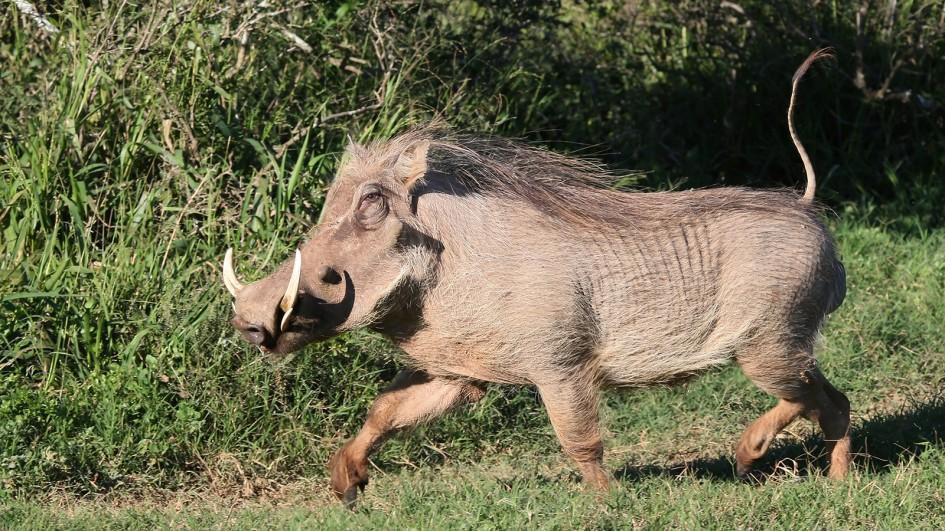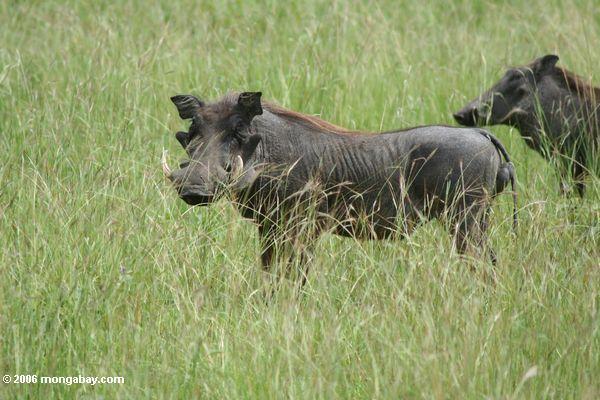The first image is the image on the left, the second image is the image on the right. Assess this claim about the two images: "One image shows a single warthog while the other shows no less than two warthogs.". Correct or not? Answer yes or no. Yes. The first image is the image on the left, the second image is the image on the right. Evaluate the accuracy of this statement regarding the images: "There are 3 warthogs in the image pair". Is it true? Answer yes or no. Yes. 